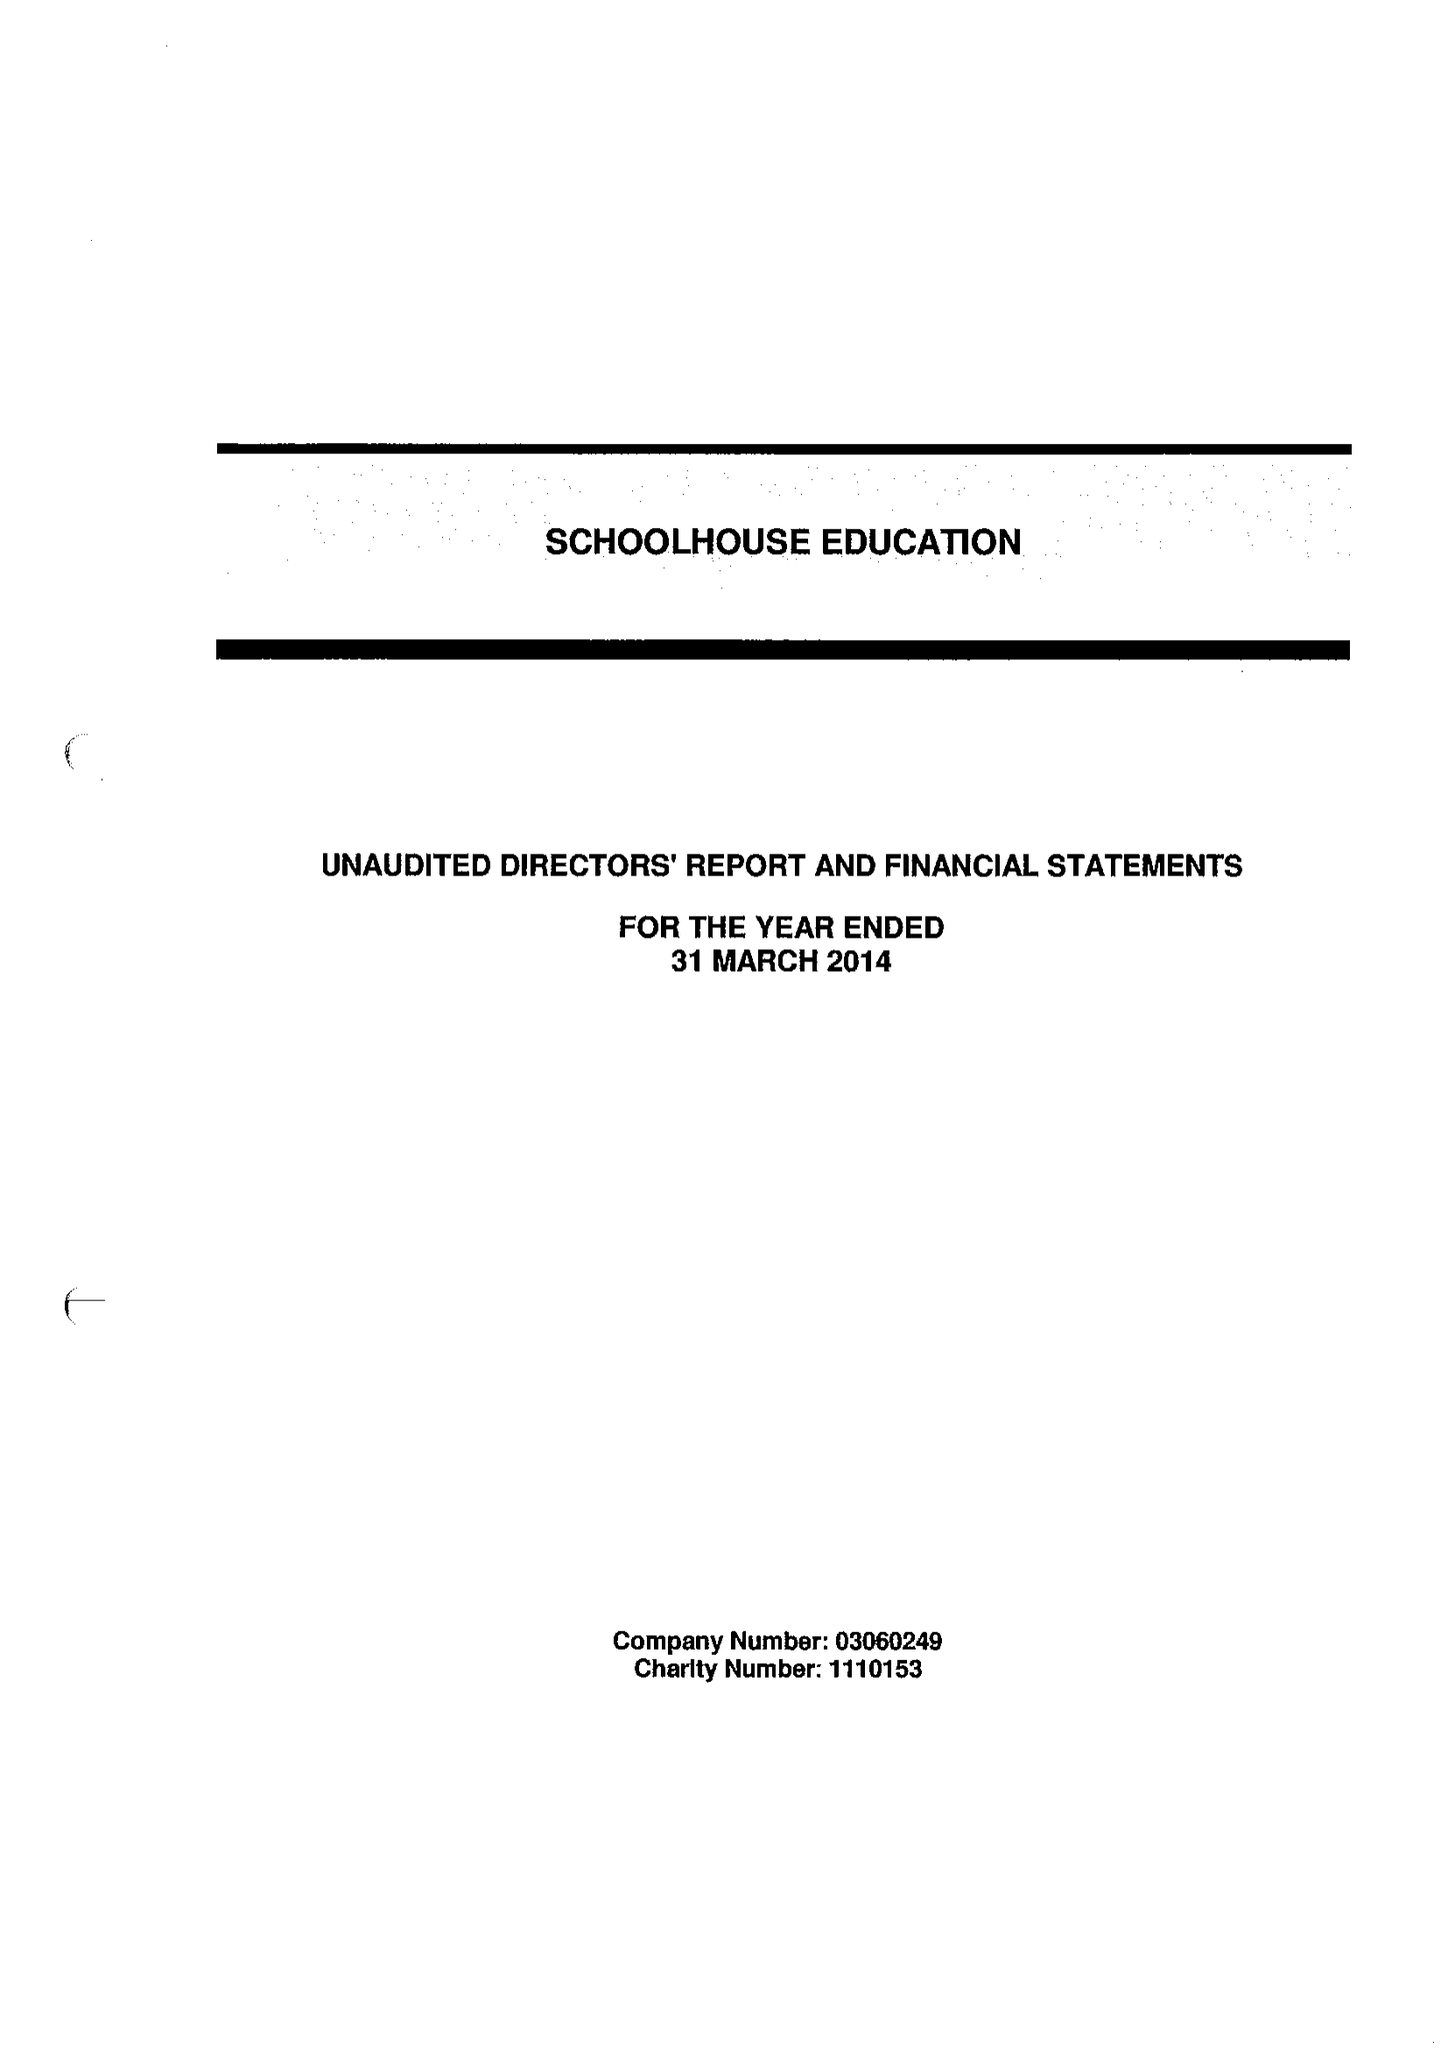What is the value for the charity_name?
Answer the question using a single word or phrase. Schoolhouse Education 